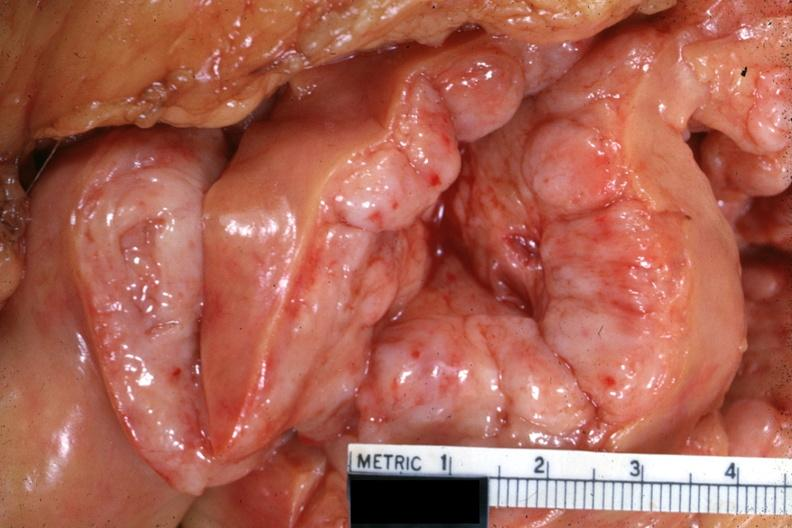what does this image show?
Answer the question using a single word or phrase. Excellent view of cut mesentery showing massively enlarged mesenteric nodes with focal hemorrhages case 